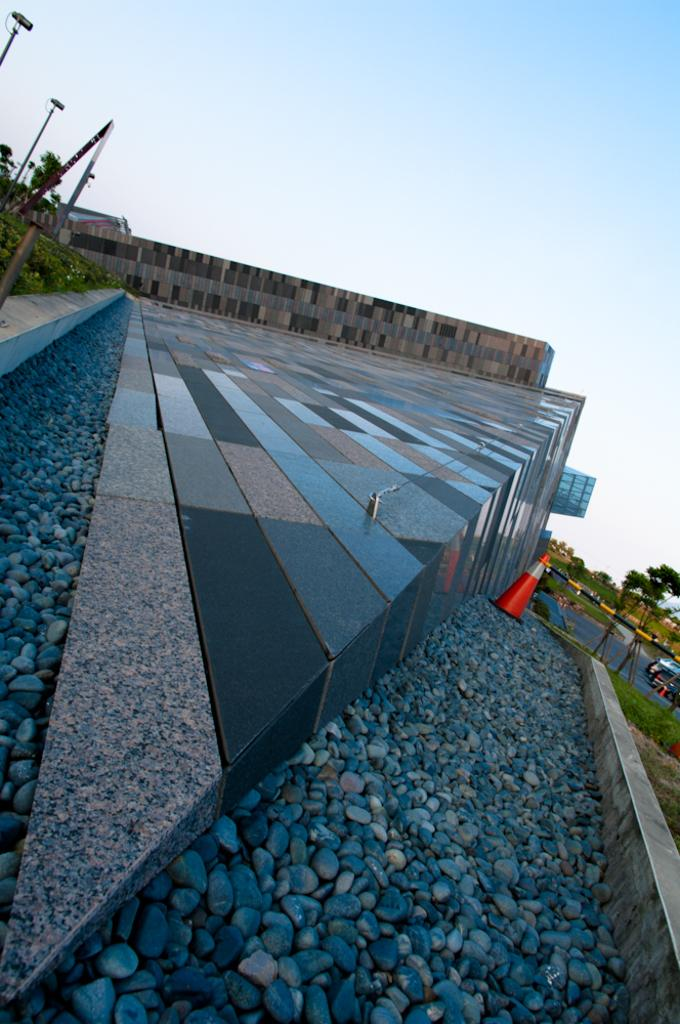What type of structure can be seen in the image? There is a building in the image. What type of material is present in the image? There are stones in the image. What type of object is present in the image that is used for safety or guidance? There is a traffic cone in the image. What type of vertical structures can be seen in the image? There are poles in the image. What type of vegetation is present in the image? There is grass and trees in the image. What type of transportation is present in the image? There is a vehicle in the image. What can be seen in the background of the image? The sky is visible in the background of the image. Can you see a bear playing with the traffic cone in the image? No, there is no bear present in the image. What type of attraction is visible in the image? There is no specific attraction mentioned in the image; it features a building, stones, a traffic cone, poles, grass, trees, a vehicle, and the sky. 